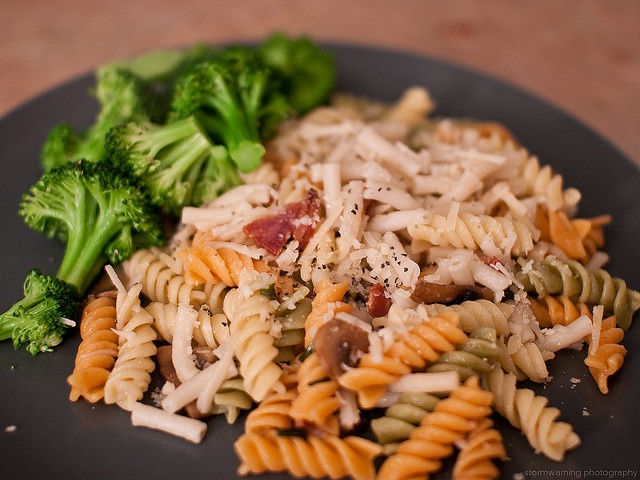Describe the objects in this image and their specific colors. I can see dining table in brown and tan tones, broccoli in brown, darkgreen, black, and olive tones, and broccoli in brown, olive, and darkgreen tones in this image. 